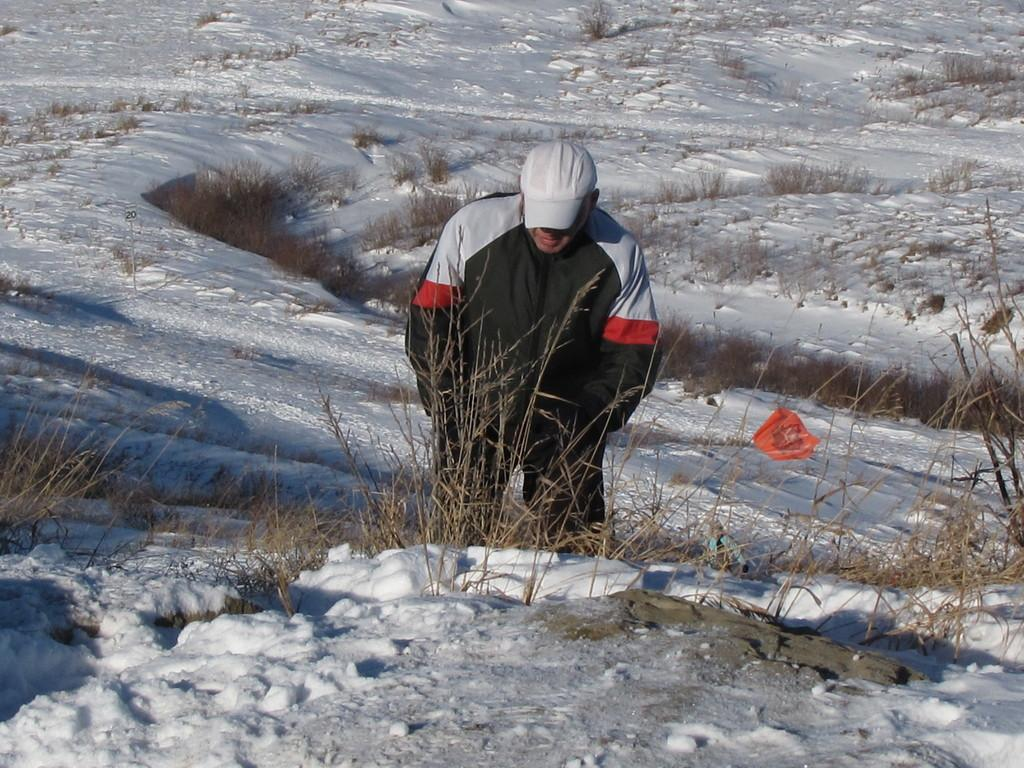Who is present in the image? There is a man in the image. What is the man wearing on his head? The man is wearing a cap. What is the condition of the ground in the image? There is snow on the ground in the image. What type of vegetation can be seen in the image? There are plants visible in the image. How many pears are on the man's hat in the image? There are no pears present in the image, and the man is not wearing a hat with pears. 